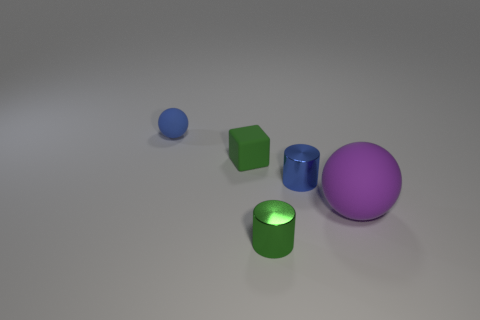Is the small green thing behind the large purple object made of the same material as the green object in front of the cube?
Offer a very short reply. No. What material is the cylinder that is right of the shiny cylinder that is in front of the big purple ball?
Your response must be concise. Metal. How big is the green thing on the right side of the tiny matte thing in front of the rubber thing that is behind the rubber cube?
Ensure brevity in your answer.  Small. Do the green matte thing and the purple ball have the same size?
Provide a succinct answer. No. Is the shape of the green thing that is in front of the purple rubber ball the same as the small green object that is behind the purple object?
Offer a terse response. No. Is there a small rubber thing behind the green object that is behind the small green shiny cylinder?
Your answer should be very brief. Yes. Are any things visible?
Keep it short and to the point. Yes. What number of cyan spheres have the same size as the green cylinder?
Your response must be concise. 0. What number of things are both in front of the small blue rubber thing and behind the large thing?
Your answer should be compact. 2. Does the green thing to the right of the cube have the same size as the small blue matte thing?
Give a very brief answer. Yes. 